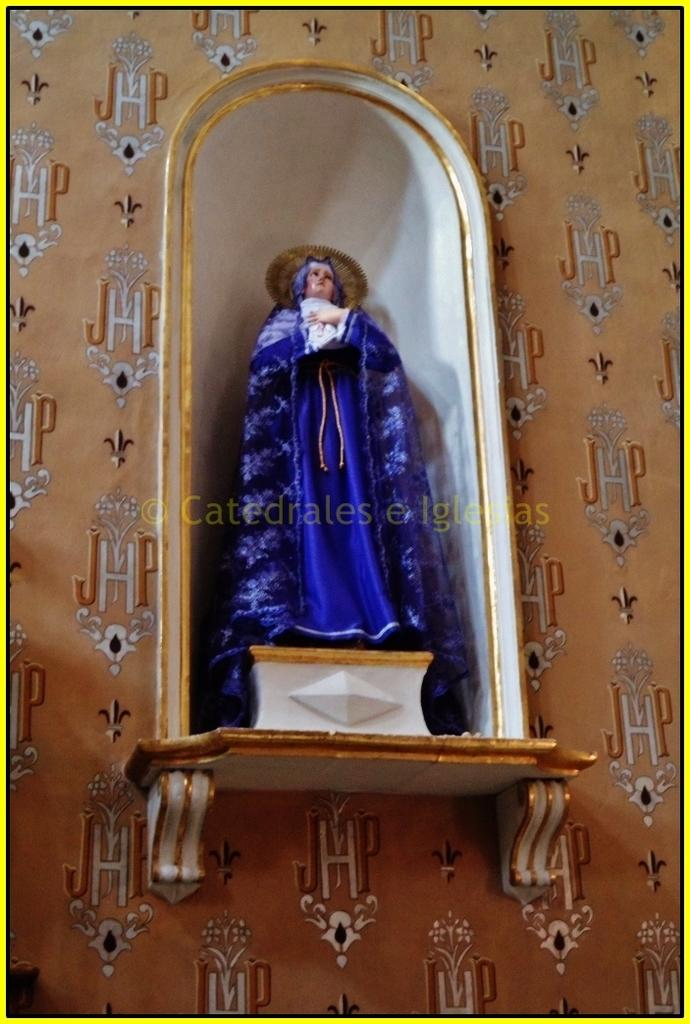What is the main subject in the center of the image? There is a statue in the center of the image. What can be seen in the background of the image? There is a wall in the background of the image. Are there any words or symbols on the wall? Yes, there is text on the wall. What type of cart is being used to transport the governor in the image? There is no cart or governor present in the image; it features a statue and a wall with text. 